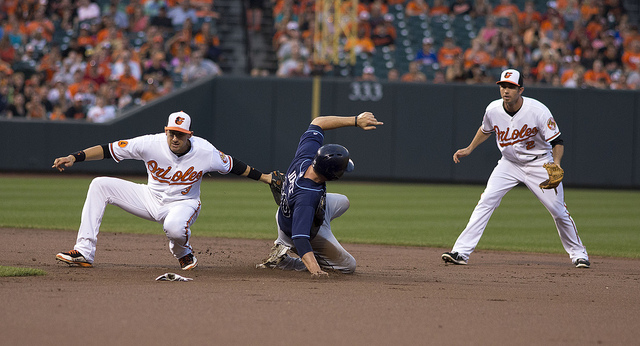<image>What team is sliding into base? I don't know which team is sliding into base. It can be orioles, rays, yankees, jays, dolphins or galaxy. What team is sliding into base? I don't know which team is sliding into base. It is unclear. 